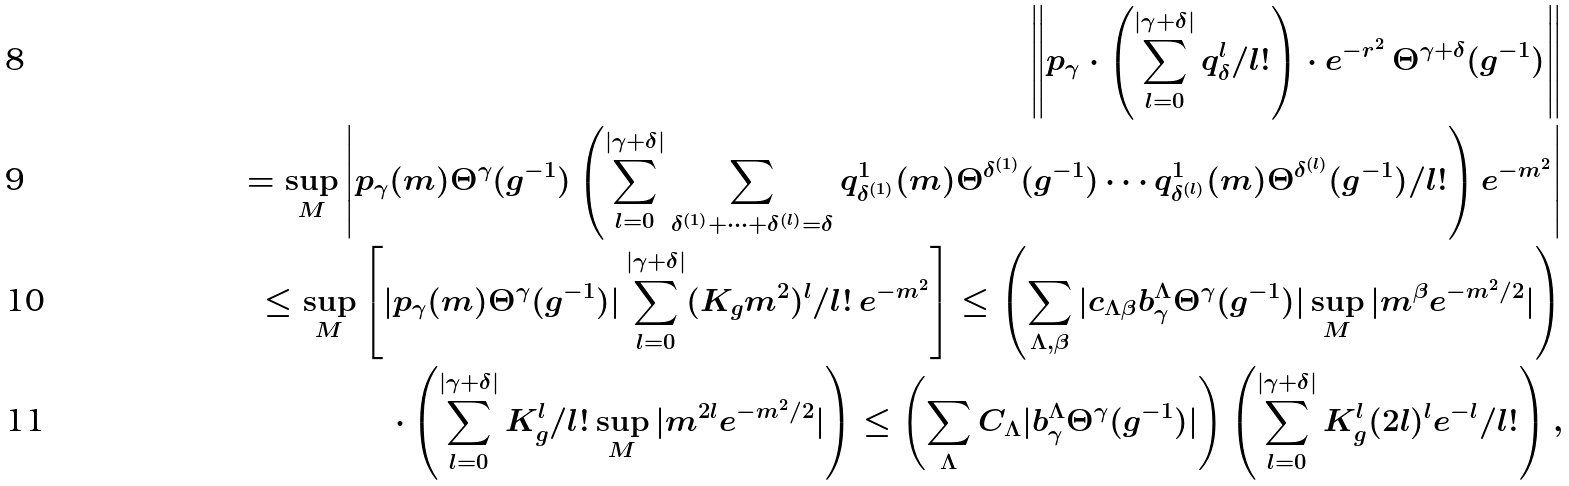<formula> <loc_0><loc_0><loc_500><loc_500>\left \| p _ { \gamma } \cdot \left ( \sum _ { l = 0 } ^ { | \gamma + \delta | } q _ { \delta } ^ { l } / l ! \right ) \cdot e ^ { - r ^ { 2 } } \, \Theta ^ { \gamma + \delta } ( g ^ { - 1 } ) \right \| \\ = \sup _ { M } \left | p _ { \gamma } ( m ) \Theta ^ { \gamma } ( g ^ { - 1 } ) \left ( \sum _ { l = 0 } ^ { | \gamma + \delta | } \sum _ { \delta ^ { ( 1 ) } + \dots + \delta ^ { ( l ) } = \delta } q _ { \delta ^ { ( 1 ) } } ^ { 1 } ( m ) \Theta ^ { \delta ^ { ( 1 ) } } ( g ^ { - 1 } ) \cdots q _ { \delta ^ { ( l ) } } ^ { 1 } ( m ) \Theta ^ { \delta ^ { ( l ) } } ( g ^ { - 1 } ) / l ! \right ) e ^ { - m ^ { 2 } } \right | \\ \leq \sup _ { M } \left [ | p _ { \gamma } ( m ) \Theta ^ { \gamma } ( g ^ { - 1 } ) | \sum _ { l = 0 } ^ { | \gamma + \delta | } ( K _ { g } m ^ { 2 } ) ^ { l } / l ! \, e ^ { - m ^ { 2 } } \right ] \leq \left ( \sum _ { \Lambda , \beta } | c _ { \Lambda \beta } b ^ { \Lambda } _ { \gamma } \Theta ^ { \gamma } ( g ^ { - 1 } ) | \sup _ { M } | m ^ { \beta } e ^ { - m ^ { 2 } / 2 } | \right ) \\ \cdot \left ( \sum _ { l = 0 } ^ { | \gamma + \delta | } K _ { g } ^ { l } / l ! \sup _ { M } | m ^ { 2 l } e ^ { - m ^ { 2 } / 2 } | \right ) \leq \left ( \sum _ { \Lambda } C _ { \Lambda } | b ^ { \Lambda } _ { \gamma } \Theta ^ { \gamma } ( g ^ { - 1 } ) | \right ) \left ( \sum _ { l = 0 } ^ { | \gamma + \delta | } K _ { g } ^ { l } ( 2 l ) ^ { l } e ^ { - l } / l ! \right ) ,</formula> 